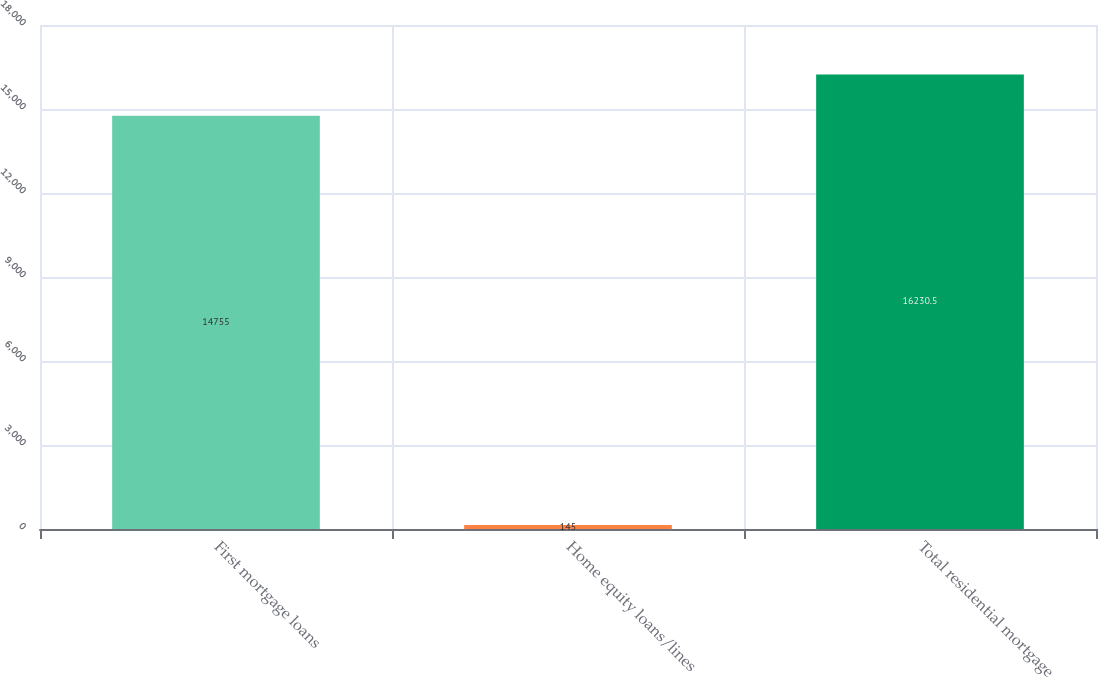<chart> <loc_0><loc_0><loc_500><loc_500><bar_chart><fcel>First mortgage loans<fcel>Home equity loans/lines<fcel>Total residential mortgage<nl><fcel>14755<fcel>145<fcel>16230.5<nl></chart> 